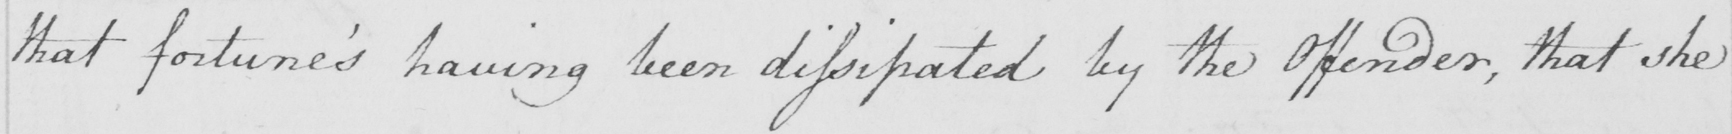What does this handwritten line say? that fortune ' s having been dissipated by the Offender , that she 